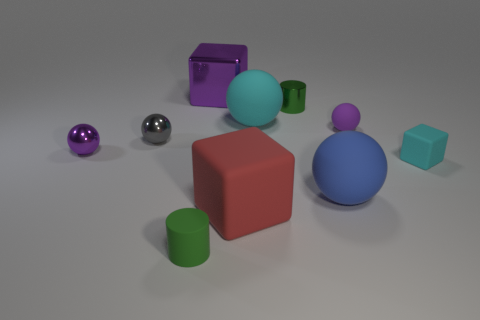There is a thing in front of the big block in front of the large metal cube; what is its material?
Your answer should be compact. Rubber. Is the size of the purple shiny object that is to the right of the green rubber cylinder the same as the cyan matte cube?
Give a very brief answer. No. Are there any big rubber balls that have the same color as the tiny block?
Give a very brief answer. Yes. How many things are either small balls to the left of the small green matte cylinder or big blocks in front of the tiny block?
Offer a very short reply. 3. Is the color of the big shiny block the same as the small rubber sphere?
Keep it short and to the point. Yes. There is another cylinder that is the same color as the tiny metallic cylinder; what material is it?
Your answer should be compact. Rubber. Are there fewer tiny cyan things right of the red rubber cube than blocks that are behind the gray thing?
Make the answer very short. No. Do the large red object and the big purple cube have the same material?
Make the answer very short. No. There is a object that is both behind the big cyan object and right of the large red cube; what size is it?
Provide a succinct answer. Small. There is a cyan matte object that is the same size as the rubber cylinder; what is its shape?
Your response must be concise. Cube. 